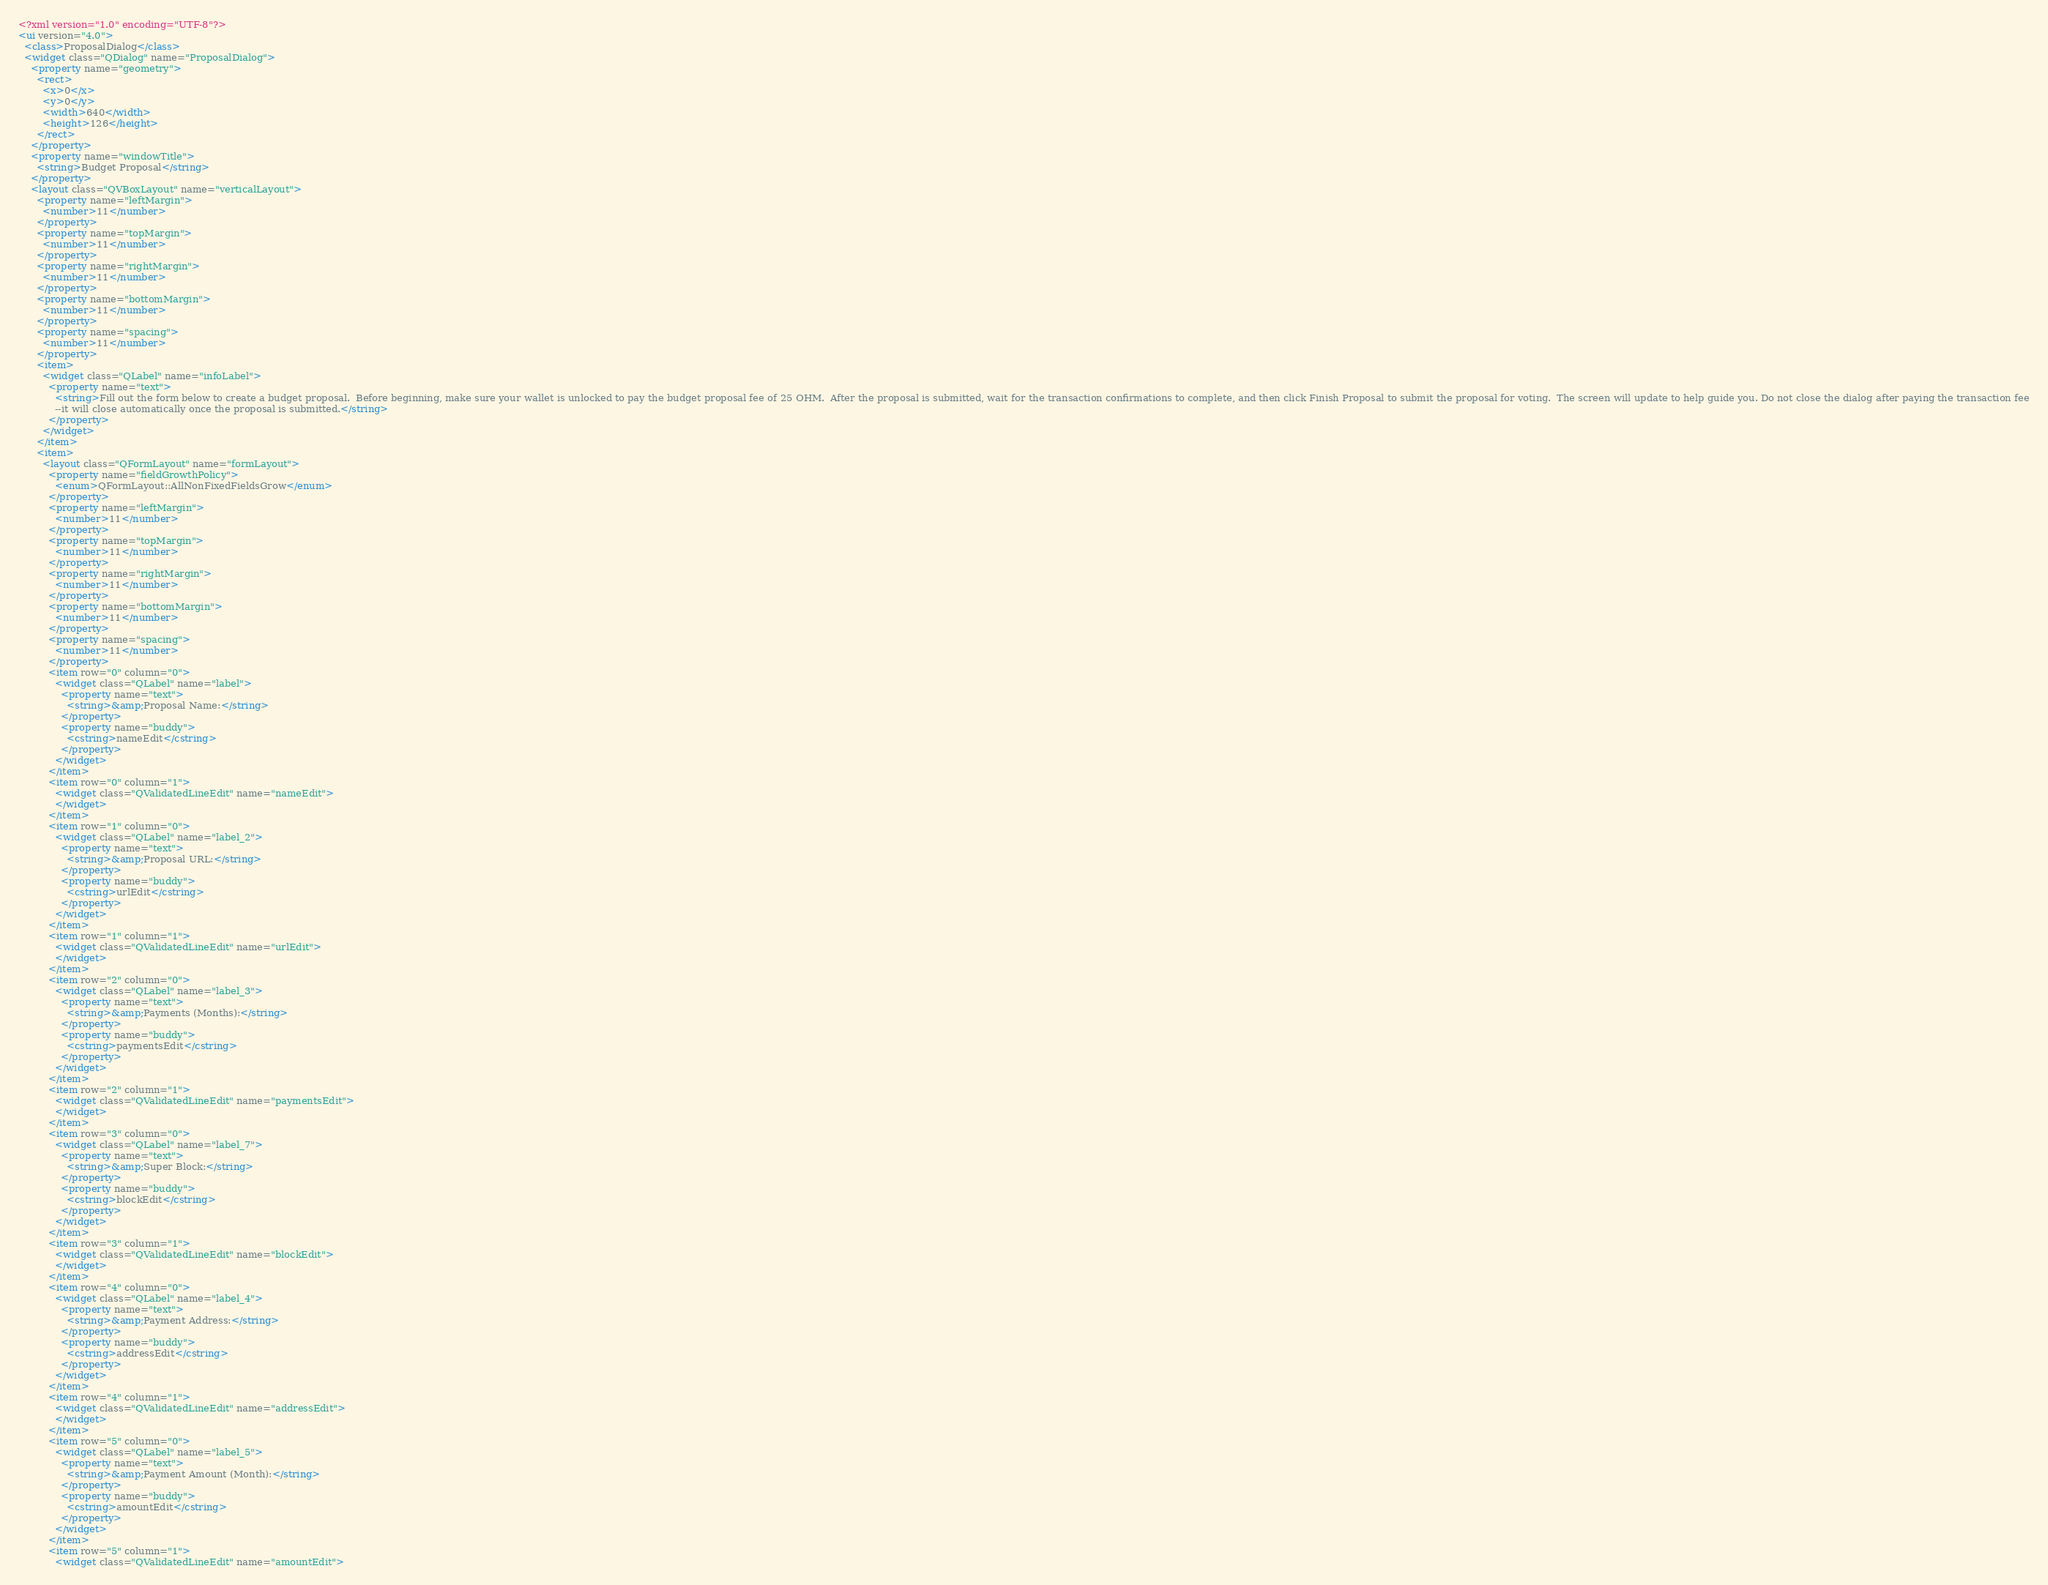Convert code to text. <code><loc_0><loc_0><loc_500><loc_500><_XML_><?xml version="1.0" encoding="UTF-8"?>
<ui version="4.0">
  <class>ProposalDialog</class>
  <widget class="QDialog" name="ProposalDialog">
    <property name="geometry">
      <rect>
        <x>0</x>
        <y>0</y>
        <width>640</width>
        <height>126</height>
      </rect>
    </property>
    <property name="windowTitle">
      <string>Budget Proposal</string>
    </property>
    <layout class="QVBoxLayout" name="verticalLayout">
      <property name="leftMargin">
        <number>11</number>
      </property>
      <property name="topMargin">
        <number>11</number>
      </property>
      <property name="rightMargin">
        <number>11</number>
      </property>
      <property name="bottomMargin">
        <number>11</number>
      </property>
      <property name="spacing">
        <number>11</number>
      </property>
      <item>
        <widget class="QLabel" name="infoLabel">
          <property name="text">
            <string>Fill out the form below to create a budget proposal.  Before beginning, make sure your wallet is unlocked to pay the budget proposal fee of 25 OHM.  After the proposal is submitted, wait for the transaction confirmations to complete, and then click Finish Proposal to submit the proposal for voting.  The screen will update to help guide you. Do not close the dialog after paying the transaction fee
            --it will close automatically once the proposal is submitted.</string>
          </property>
        </widget>
      </item>
      <item>
        <layout class="QFormLayout" name="formLayout">
          <property name="fieldGrowthPolicy">
            <enum>QFormLayout::AllNonFixedFieldsGrow</enum>
          </property>
          <property name="leftMargin">
            <number>11</number>
          </property>
          <property name="topMargin">
            <number>11</number>
          </property>
          <property name="rightMargin">
            <number>11</number>
          </property>
          <property name="bottomMargin">
            <number>11</number>
          </property>
          <property name="spacing">
            <number>11</number>
          </property>
          <item row="0" column="0">
            <widget class="QLabel" name="label">
              <property name="text">
                <string>&amp;Proposal Name:</string>
              </property>
              <property name="buddy">
                <cstring>nameEdit</cstring>
              </property>
            </widget>
          </item>
          <item row="0" column="1">
            <widget class="QValidatedLineEdit" name="nameEdit">
            </widget>
          </item>
          <item row="1" column="0">
            <widget class="QLabel" name="label_2">
              <property name="text">
                <string>&amp;Proposal URL:</string>
              </property>
              <property name="buddy">
                <cstring>urlEdit</cstring>
              </property>
            </widget>
          </item>
          <item row="1" column="1">
            <widget class="QValidatedLineEdit" name="urlEdit">
            </widget>
          </item>
          <item row="2" column="0">
            <widget class="QLabel" name="label_3">
              <property name="text">
                <string>&amp;Payments (Months):</string>
              </property>
              <property name="buddy">
                <cstring>paymentsEdit</cstring>
              </property>
            </widget>
          </item>
          <item row="2" column="1">
            <widget class="QValidatedLineEdit" name="paymentsEdit">
            </widget>
          </item>
          <item row="3" column="0">
            <widget class="QLabel" name="label_7">
              <property name="text">
                <string>&amp;Super Block:</string>
              </property>
              <property name="buddy">
                <cstring>blockEdit</cstring>
              </property>
            </widget>
          </item>
          <item row="3" column="1">
            <widget class="QValidatedLineEdit" name="blockEdit">
            </widget>
          </item>
          <item row="4" column="0">
            <widget class="QLabel" name="label_4">
              <property name="text">
                <string>&amp;Payment Address:</string>
              </property>
              <property name="buddy">
                <cstring>addressEdit</cstring>
              </property>
            </widget>
          </item>
          <item row="4" column="1">
            <widget class="QValidatedLineEdit" name="addressEdit">
            </widget>
          </item>
          <item row="5" column="0">
            <widget class="QLabel" name="label_5">
              <property name="text">
                <string>&amp;Payment Amount (Month):</string>
              </property>
              <property name="buddy">
                <cstring>amountEdit</cstring>
              </property>
            </widget>
          </item>
          <item row="5" column="1">
            <widget class="QValidatedLineEdit" name="amountEdit"></code> 